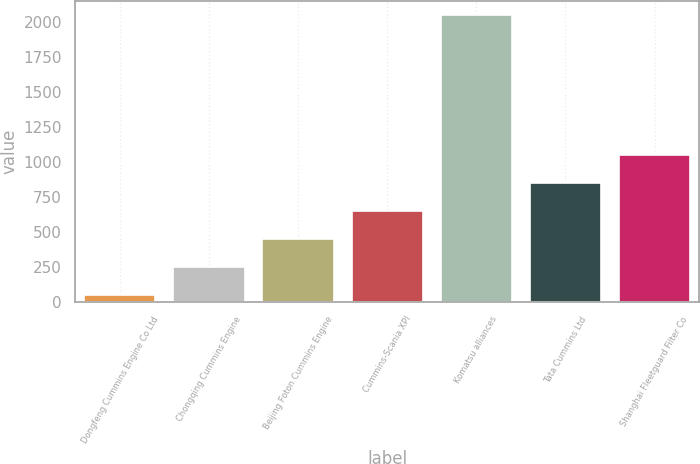<chart> <loc_0><loc_0><loc_500><loc_500><bar_chart><fcel>Dongfeng Cummins Engine Co Ltd<fcel>Chongqing Cummins Engine<fcel>Beijing Foton Cummins Engine<fcel>Cummins-Scania XPI<fcel>Komatsu alliances<fcel>Tata Cummins Ltd<fcel>Shanghai Fleetguard Filter Co<nl><fcel>50<fcel>250<fcel>450<fcel>650<fcel>2050<fcel>850<fcel>1050<nl></chart> 